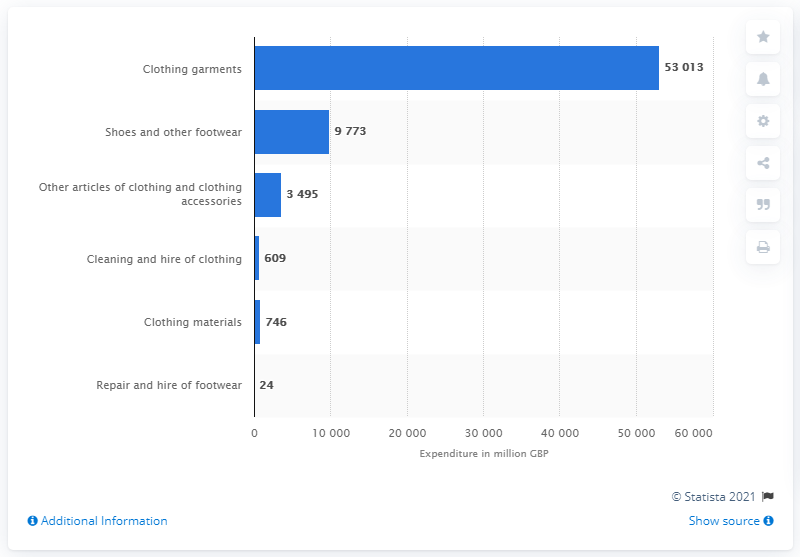Mention a couple of crucial points in this snapshot. In 2020, the amount of money spent on shoes in the UK was 9,773. 